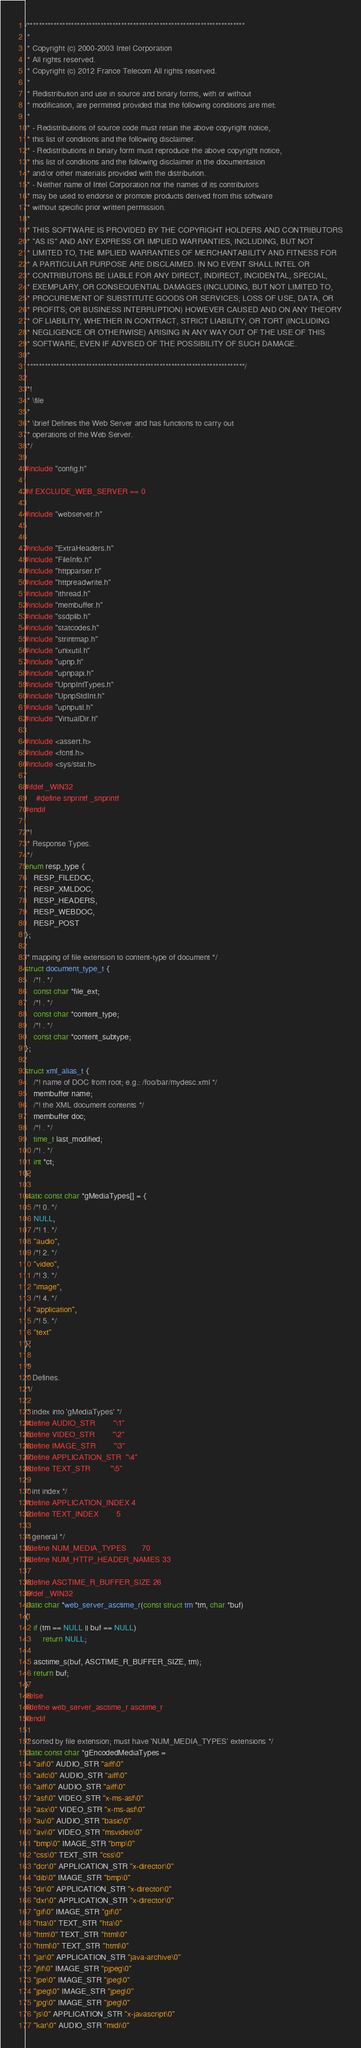<code> <loc_0><loc_0><loc_500><loc_500><_C_>/**************************************************************************
 *
 * Copyright (c) 2000-2003 Intel Corporation
 * All rights reserved.
 * Copyright (c) 2012 France Telecom All rights reserved.
 *
 * Redistribution and use in source and binary forms, with or without
 * modification, are permitted provided that the following conditions are met:
 *
 * - Redistributions of source code must retain the above copyright notice,
 * this list of conditions and the following disclaimer.
 * - Redistributions in binary form must reproduce the above copyright notice,
 * this list of conditions and the following disclaimer in the documentation
 * and/or other materials provided with the distribution.
 * - Neither name of Intel Corporation nor the names of its contributors
 * may be used to endorse or promote products derived from this software
 * without specific prior written permission.
 *
 * THIS SOFTWARE IS PROVIDED BY THE COPYRIGHT HOLDERS AND CONTRIBUTORS
 * "AS IS" AND ANY EXPRESS OR IMPLIED WARRANTIES, INCLUDING, BUT NOT
 * LIMITED TO, THE IMPLIED WARRANTIES OF MERCHANTABILITY AND FITNESS FOR
 * A PARTICULAR PURPOSE ARE DISCLAIMED. IN NO EVENT SHALL INTEL OR
 * CONTRIBUTORS BE LIABLE FOR ANY DIRECT, INDIRECT, INCIDENTAL, SPECIAL,
 * EXEMPLARY, OR CONSEQUENTIAL DAMAGES (INCLUDING, BUT NOT LIMITED TO,
 * PROCUREMENT OF SUBSTITUTE GOODS OR SERVICES; LOSS OF USE, DATA, OR
 * PROFITS; OR BUSINESS INTERRUPTION) HOWEVER CAUSED AND ON ANY THEORY
 * OF LIABILITY, WHETHER IN CONTRACT, STRICT LIABILITY, OR TORT (INCLUDING
 * NEGLIGENCE OR OTHERWISE) ARISING IN ANY WAY OUT OF THE USE OF THIS
 * SOFTWARE, EVEN IF ADVISED OF THE POSSIBILITY OF SUCH DAMAGE.
 *
 **************************************************************************/

/*!
 * \file
 *
 * \brief Defines the Web Server and has functions to carry out
 * operations of the Web Server.
 */

#include "config.h"

#if EXCLUDE_WEB_SERVER == 0

#include "webserver.h"


#include "ExtraHeaders.h"
#include "FileInfo.h"
#include "httpparser.h"
#include "httpreadwrite.h"
#include "ithread.h"
#include "membuffer.h"
#include "ssdplib.h"
#include "statcodes.h"
#include "strintmap.h"
#include "unixutil.h"
#include "upnp.h"
#include "upnpapi.h"
#include "UpnpIntTypes.h"
#include "UpnpStdInt.h"
#include "upnputil.h"
#include "VirtualDir.h"

#include <assert.h>
#include <fcntl.h>
#include <sys/stat.h>

#ifdef _WIN32
	 #define snprintf _snprintf
#endif

/*!
 * Response Types.
 */
enum resp_type {
	RESP_FILEDOC,
	RESP_XMLDOC,
	RESP_HEADERS,
	RESP_WEBDOC,
	RESP_POST
};

/* mapping of file extension to content-type of document */
struct document_type_t {
	/*! . */
	const char *file_ext;
	/*! . */
	const char *content_type;
	/*! . */
	const char *content_subtype;
};

struct xml_alias_t {
	/*! name of DOC from root; e.g.: /foo/bar/mydesc.xml */
	membuffer name;
	/*! the XML document contents */
	membuffer doc;
	/*! . */
	time_t last_modified;
	/*! . */
	int *ct;
};

static const char *gMediaTypes[] = {
	/*! 0. */
	NULL,
	/*! 1. */
	"audio",
	/*! 2. */
	"video",
	/*! 3. */
	"image",
	/*! 4. */
	"application",
	/*! 5. */
	"text"
};

/*
 * Defines.
 */

/* index into 'gMediaTypes' */
#define AUDIO_STR        "\1"
#define VIDEO_STR        "\2"
#define IMAGE_STR        "\3"
#define APPLICATION_STR  "\4"
#define TEXT_STR         "\5"

/* int index */
#define APPLICATION_INDEX 4
#define TEXT_INDEX        5

/* general */
#define NUM_MEDIA_TYPES       70
#define NUM_HTTP_HEADER_NAMES 33

#define ASCTIME_R_BUFFER_SIZE 26
#ifdef _WIN32
static char *web_server_asctime_r(const struct tm *tm, char *buf)
{
	if (tm == NULL || buf == NULL)
		return NULL;

	asctime_s(buf, ASCTIME_R_BUFFER_SIZE, tm);
	return buf;
}
#else
#define web_server_asctime_r asctime_r
#endif

/* sorted by file extension; must have 'NUM_MEDIA_TYPES' extensions */
static const char *gEncodedMediaTypes =
	"aif\0" AUDIO_STR "aiff\0"
	"aifc\0" AUDIO_STR "aiff\0"
	"aiff\0" AUDIO_STR "aiff\0"
	"asf\0" VIDEO_STR "x-ms-asf\0"
	"asx\0" VIDEO_STR "x-ms-asf\0"
	"au\0" AUDIO_STR "basic\0"
	"avi\0" VIDEO_STR "msvideo\0"
	"bmp\0" IMAGE_STR "bmp\0"
	"css\0" TEXT_STR "css\0"
	"dcr\0" APPLICATION_STR "x-director\0"
	"dib\0" IMAGE_STR "bmp\0"
	"dir\0" APPLICATION_STR "x-director\0"
	"dxr\0" APPLICATION_STR "x-director\0"
	"gif\0" IMAGE_STR "gif\0"
	"hta\0" TEXT_STR "hta\0"
	"htm\0" TEXT_STR "html\0"
	"html\0" TEXT_STR "html\0"
	"jar\0" APPLICATION_STR "java-archive\0"
	"jfif\0" IMAGE_STR "pjpeg\0"
	"jpe\0" IMAGE_STR "jpeg\0"
	"jpeg\0" IMAGE_STR "jpeg\0"
	"jpg\0" IMAGE_STR "jpeg\0"
	"js\0" APPLICATION_STR "x-javascript\0"
	"kar\0" AUDIO_STR "midi\0"</code> 